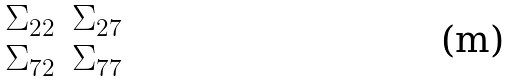<formula> <loc_0><loc_0><loc_500><loc_500>\begin{matrix} \Sigma _ { 2 2 } & \Sigma _ { 2 7 } \\ \Sigma _ { 7 2 } & \Sigma _ { 7 7 } \\ \end{matrix}</formula> 